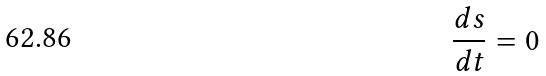<formula> <loc_0><loc_0><loc_500><loc_500>\frac { d s } { d t } = 0</formula> 